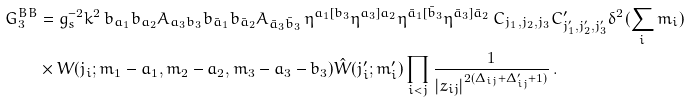Convert formula to latex. <formula><loc_0><loc_0><loc_500><loc_500>G ^ { B B } _ { 3 } & = g _ { s } ^ { - 2 } k ^ { 2 } \, b _ { a _ { 1 } } b _ { a _ { 2 } } A _ { a _ { 3 } b _ { 3 } } b _ { \bar { a } _ { 1 } } b _ { \bar { a } _ { 2 } } A _ { \bar { a } _ { 3 } \bar { b } _ { 3 } } \, \eta ^ { a _ { 1 } [ b _ { 3 } } \eta ^ { a _ { 3 } ] a _ { 2 } } \eta ^ { \bar { a } _ { 1 } [ \bar { b } _ { 3 } } \eta ^ { \bar { a } _ { 3 } ] \bar { a } _ { 2 } } \, C _ { j _ { 1 } , j _ { 2 } , j _ { 3 } } C ^ { \prime } _ { j ^ { \prime } _ { 1 } , j ^ { \prime } _ { 2 } , j ^ { \prime } _ { 3 } } \delta ^ { 2 } ( { \sum _ { i } m _ { i } } ) \\ & \times W ( j _ { i } ; m _ { 1 } - a _ { 1 } , m _ { 2 } - a _ { 2 } , m _ { 3 } - a _ { 3 } - b _ { 3 } ) \hat { W } ( j ^ { \prime } _ { i } ; m ^ { \prime } _ { i } ) \prod _ { i < j } \frac { 1 } { | z _ { i j } | ^ { 2 ( \Delta _ { i j } + \Delta ^ { \prime } _ { i j } + 1 ) } } \, .</formula> 